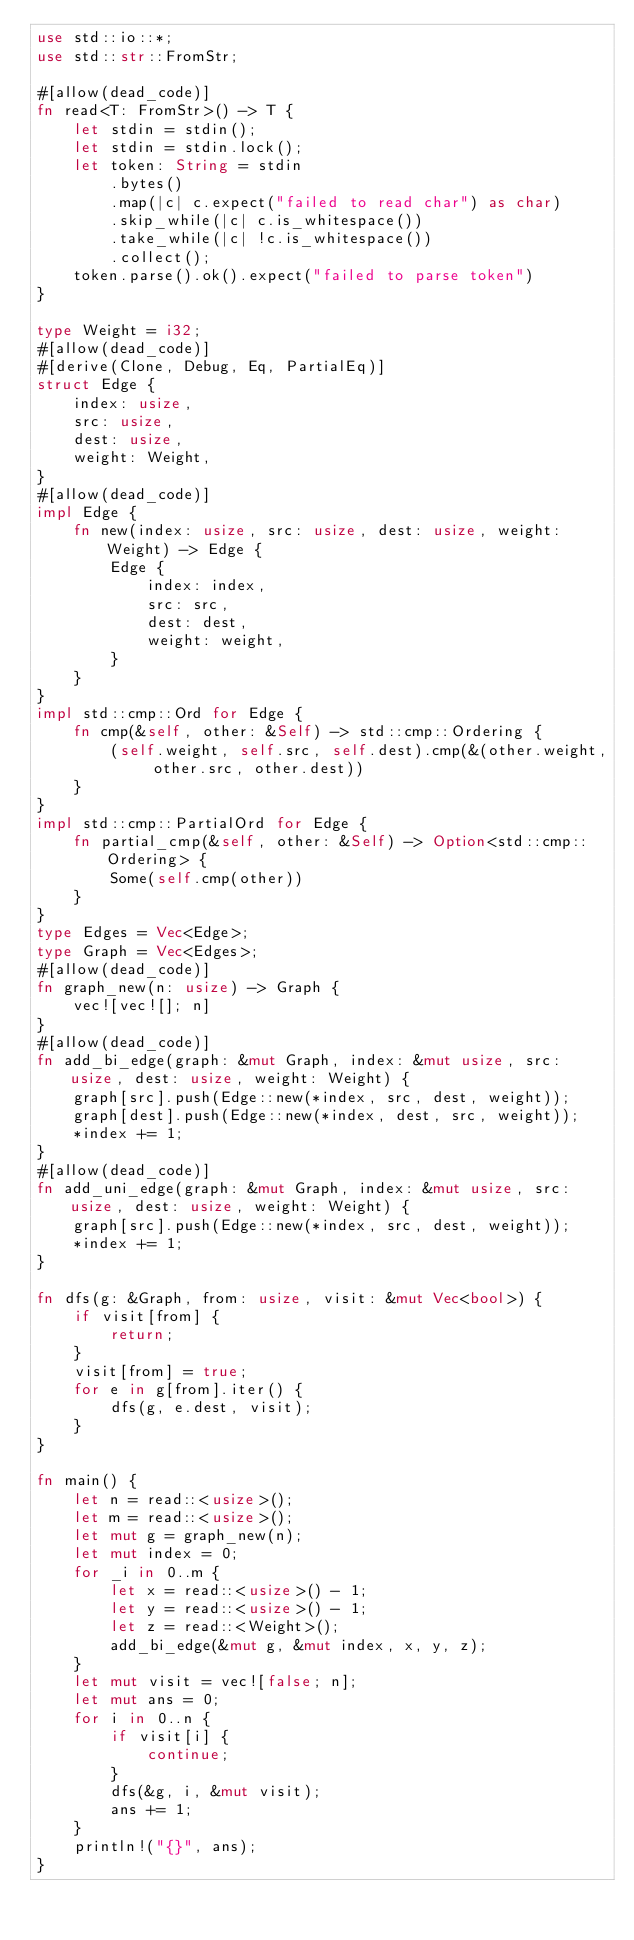Convert code to text. <code><loc_0><loc_0><loc_500><loc_500><_Rust_>use std::io::*;
use std::str::FromStr;

#[allow(dead_code)]
fn read<T: FromStr>() -> T {
    let stdin = stdin();
    let stdin = stdin.lock();
    let token: String = stdin
        .bytes()
        .map(|c| c.expect("failed to read char") as char)
        .skip_while(|c| c.is_whitespace())
        .take_while(|c| !c.is_whitespace())
        .collect();
    token.parse().ok().expect("failed to parse token")
}

type Weight = i32;
#[allow(dead_code)]
#[derive(Clone, Debug, Eq, PartialEq)]
struct Edge {
    index: usize,
    src: usize,
    dest: usize,
    weight: Weight,
}
#[allow(dead_code)]
impl Edge {
    fn new(index: usize, src: usize, dest: usize, weight: Weight) -> Edge {
        Edge {
            index: index,
            src: src,
            dest: dest,
            weight: weight,
        }
    }
}
impl std::cmp::Ord for Edge {
    fn cmp(&self, other: &Self) -> std::cmp::Ordering {
        (self.weight, self.src, self.dest).cmp(&(other.weight, other.src, other.dest))
    }
}
impl std::cmp::PartialOrd for Edge {
    fn partial_cmp(&self, other: &Self) -> Option<std::cmp::Ordering> {
        Some(self.cmp(other))
    }
}
type Edges = Vec<Edge>;
type Graph = Vec<Edges>;
#[allow(dead_code)]
fn graph_new(n: usize) -> Graph {
    vec![vec![]; n]
}
#[allow(dead_code)]
fn add_bi_edge(graph: &mut Graph, index: &mut usize, src: usize, dest: usize, weight: Weight) {
    graph[src].push(Edge::new(*index, src, dest, weight));
    graph[dest].push(Edge::new(*index, dest, src, weight));
    *index += 1;
}
#[allow(dead_code)]
fn add_uni_edge(graph: &mut Graph, index: &mut usize, src: usize, dest: usize, weight: Weight) {
    graph[src].push(Edge::new(*index, src, dest, weight));
    *index += 1;
}

fn dfs(g: &Graph, from: usize, visit: &mut Vec<bool>) {
    if visit[from] {
        return;
    }
    visit[from] = true;
    for e in g[from].iter() {
        dfs(g, e.dest, visit);
    }
}

fn main() {
    let n = read::<usize>();
    let m = read::<usize>();
    let mut g = graph_new(n);
    let mut index = 0;
    for _i in 0..m {
        let x = read::<usize>() - 1;
        let y = read::<usize>() - 1;
        let z = read::<Weight>();
        add_bi_edge(&mut g, &mut index, x, y, z);
    }
    let mut visit = vec![false; n];
    let mut ans = 0;
    for i in 0..n {
        if visit[i] {
            continue;
        }
        dfs(&g, i, &mut visit);
        ans += 1;
    }
    println!("{}", ans);
}
</code> 